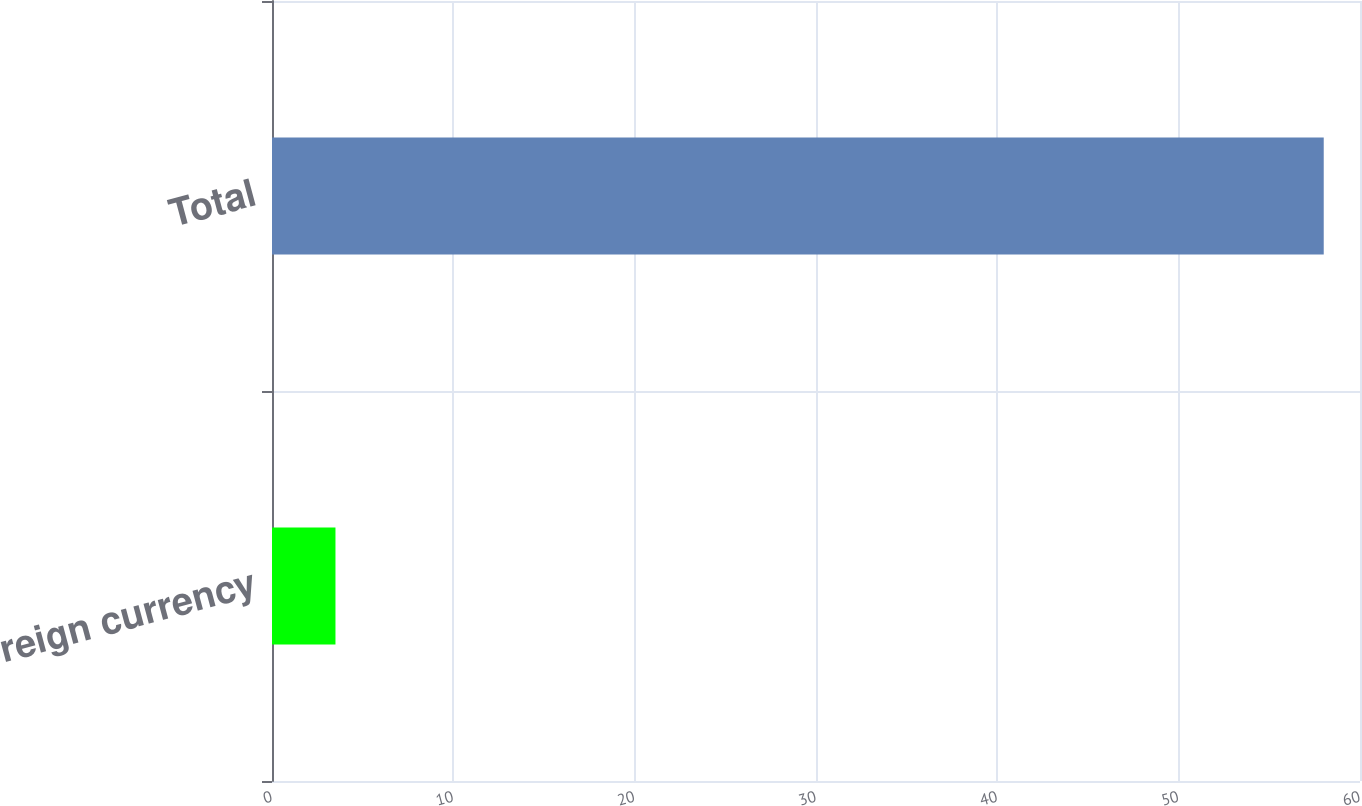<chart> <loc_0><loc_0><loc_500><loc_500><bar_chart><fcel>Foreign currency<fcel>Total<nl><fcel>3.5<fcel>58<nl></chart> 